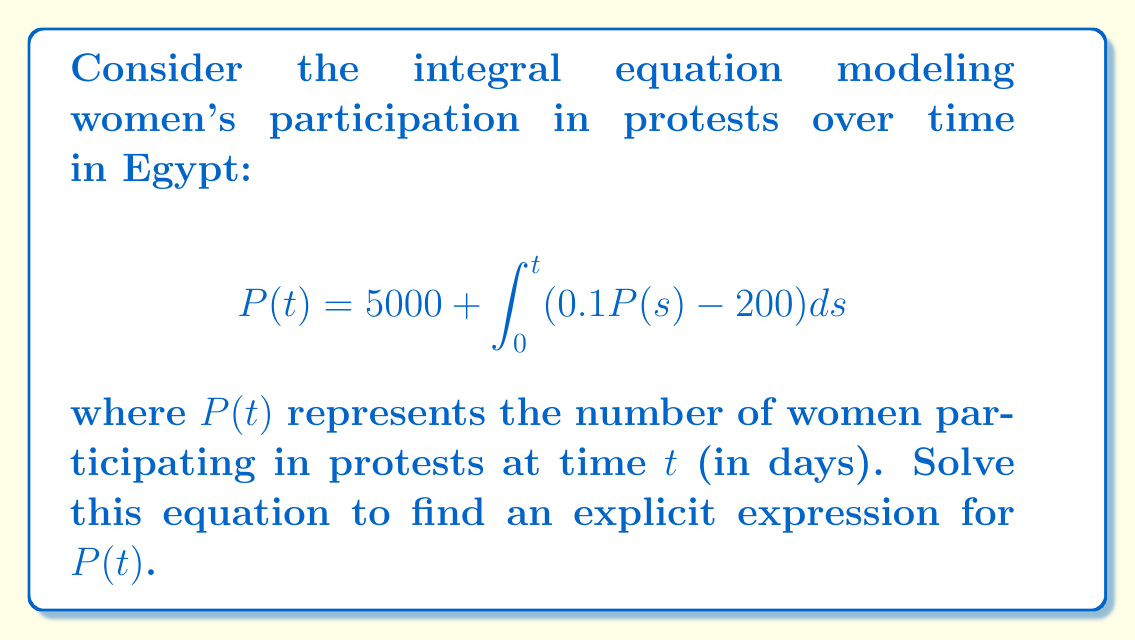Give your solution to this math problem. Let's solve this integral equation step-by-step:

1) First, we differentiate both sides of the equation with respect to $t$:
   
   $$\frac{d}{dt}P(t) = \frac{d}{dt}\left(5000 + \int_0^t (0.1P(s) - 200)ds\right)$$

2) Using the Fundamental Theorem of Calculus, we get:
   
   $$P'(t) = 0.1P(t) - 200$$

3) This is now a first-order linear differential equation. We can solve it using the integrating factor method.

4) The integrating factor is $e^{-0.1t}$. Multiply both sides by this:
   
   $$e^{-0.1t}P'(t) - 0.1e^{-0.1t}P(t) = -200e^{-0.1t}$$

5) The left side is now the derivative of $e^{-0.1t}P(t)$:
   
   $$\frac{d}{dt}(e^{-0.1t}P(t)) = -200e^{-0.1t}$$

6) Integrate both sides:
   
   $$e^{-0.1t}P(t) = 2000e^{-0.1t} + C$$

7) Solve for $P(t)$:
   
   $$P(t) = 2000 + Ce^{0.1t}$$

8) To find $C$, use the initial condition $P(0) = 5000$:
   
   $$5000 = 2000 + C$$
   $$C = 3000$$

9) Therefore, the final solution is:
   
   $$P(t) = 2000 + 3000e^{0.1t}$$

This equation models the growth of women's participation in protests over time, starting from 5000 participants and increasing exponentially.
Answer: $P(t) = 2000 + 3000e^{0.1t}$ 